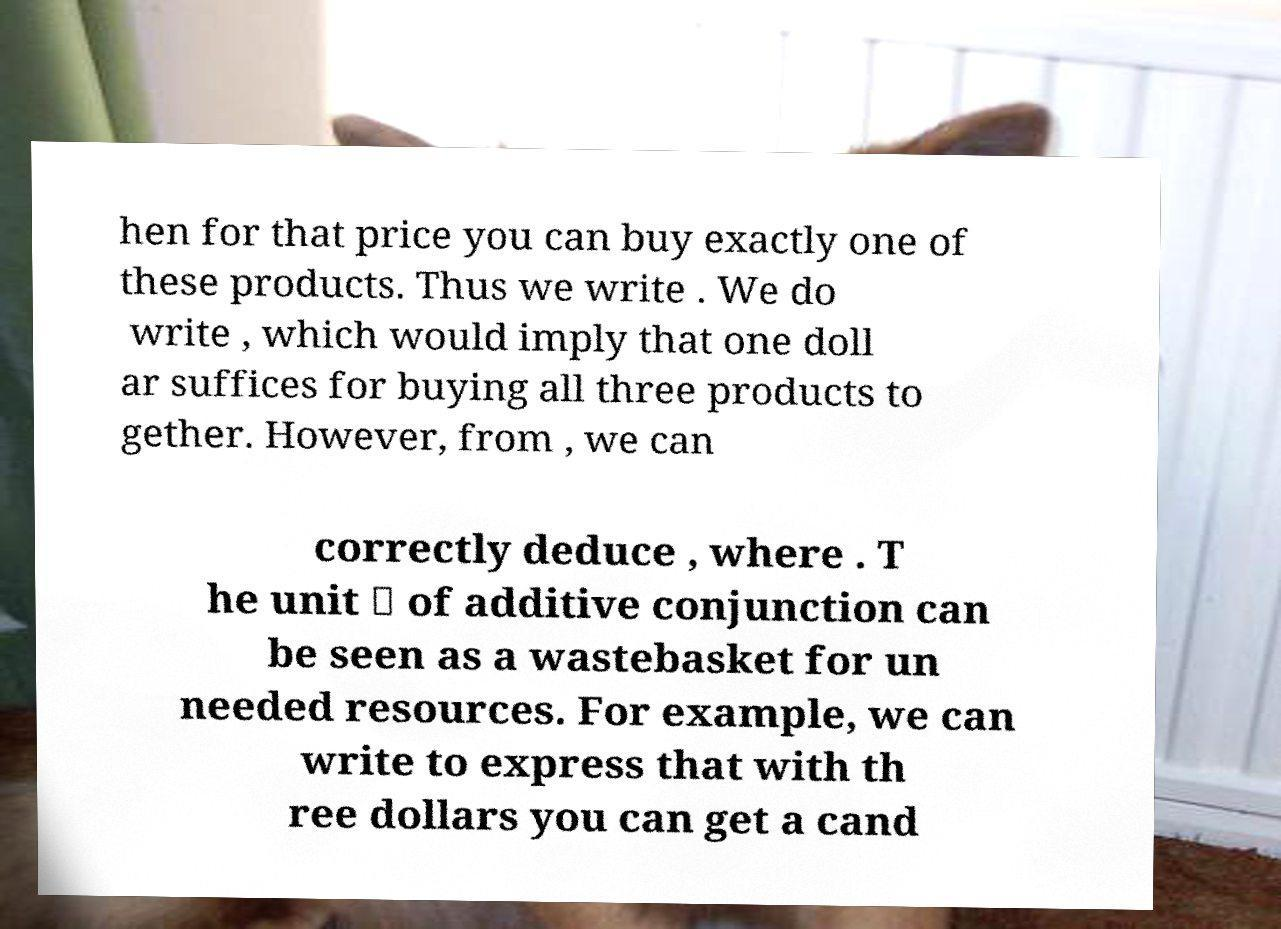Please identify and transcribe the text found in this image. hen for that price you can buy exactly one of these products. Thus we write . We do write , which would imply that one doll ar suffices for buying all three products to gether. However, from , we can correctly deduce , where . T he unit ⊤ of additive conjunction can be seen as a wastebasket for un needed resources. For example, we can write to express that with th ree dollars you can get a cand 